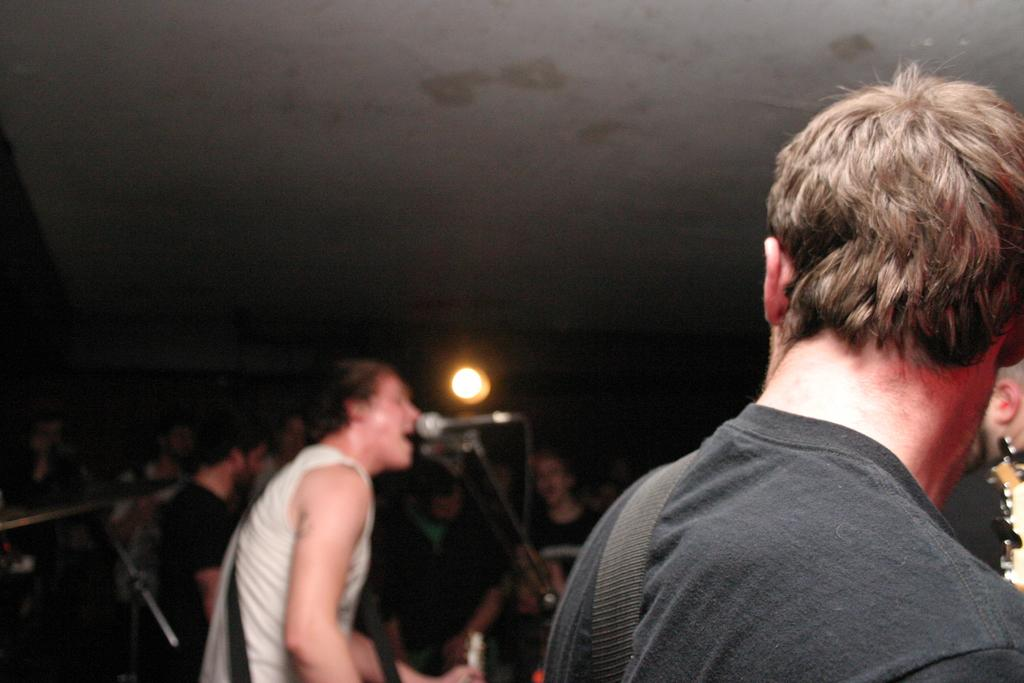What are the persons in the image doing? The persons in the image are performing. What objects are present that are related to the performance? There are musical instruments in the image. Can you describe the lighting in the image? There is a light in the image. How many lizards can be seen crawling on the musical instruments in the image? There are no lizards present in the image; it only features persons performing and musical instruments. 